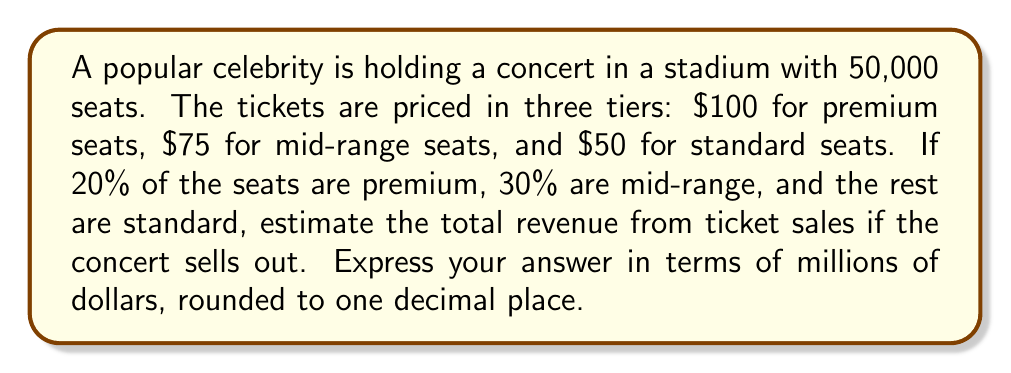Solve this math problem. Let's break this down step-by-step:

1. Calculate the number of seats in each tier:
   Premium: $20\% \times 50,000 = 0.2 \times 50,000 = 10,000$ seats
   Mid-range: $30\% \times 50,000 = 0.3 \times 50,000 = 15,000$ seats
   Standard: $50,000 - 10,000 - 15,000 = 25,000$ seats

2. Calculate the revenue from each tier:
   Premium: $10,000 \times \$100 = \$1,000,000$
   Mid-range: $15,000 \times \$75 = \$1,125,000$
   Standard: $25,000 \times \$50 = \$1,250,000$

3. Sum up the total revenue:
   Total revenue = $\$1,000,000 + \$1,125,000 + \$1,250,000 = \$3,375,000$

4. Convert to millions and round to one decimal place:
   $\$3,375,000 = \$3.375$ million
   Rounded to one decimal place: $\$3.4$ million
Answer: $\$3.4$ million 